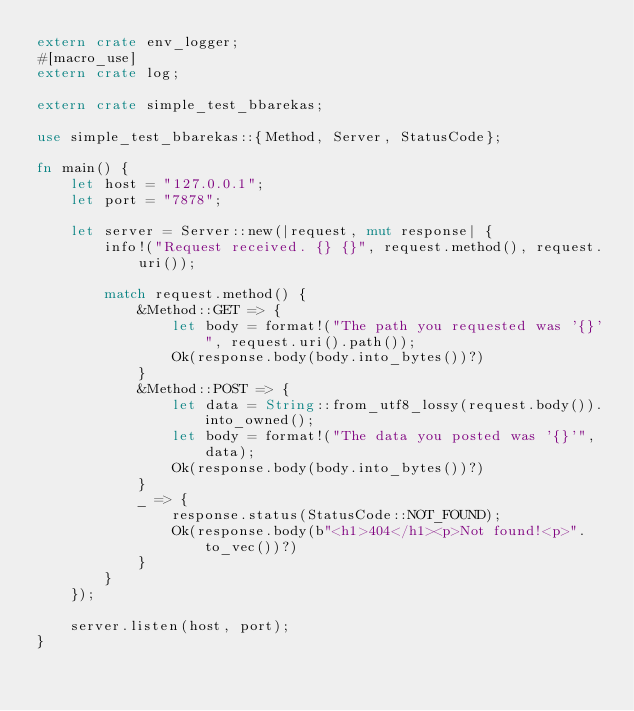Convert code to text. <code><loc_0><loc_0><loc_500><loc_500><_Rust_>extern crate env_logger;
#[macro_use]
extern crate log;

extern crate simple_test_bbarekas;

use simple_test_bbarekas::{Method, Server, StatusCode};

fn main() {
    let host = "127.0.0.1";
    let port = "7878";

    let server = Server::new(|request, mut response| {
        info!("Request received. {} {}", request.method(), request.uri());

        match request.method() {
            &Method::GET => {
                let body = format!("The path you requested was '{}'", request.uri().path());
                Ok(response.body(body.into_bytes())?)
            }
            &Method::POST => {
                let data = String::from_utf8_lossy(request.body()).into_owned();
                let body = format!("The data you posted was '{}'", data);
                Ok(response.body(body.into_bytes())?)
            }
            _ => {
                response.status(StatusCode::NOT_FOUND);
                Ok(response.body(b"<h1>404</h1><p>Not found!<p>".to_vec())?)
            }
        }
    });

    server.listen(host, port);
}
</code> 